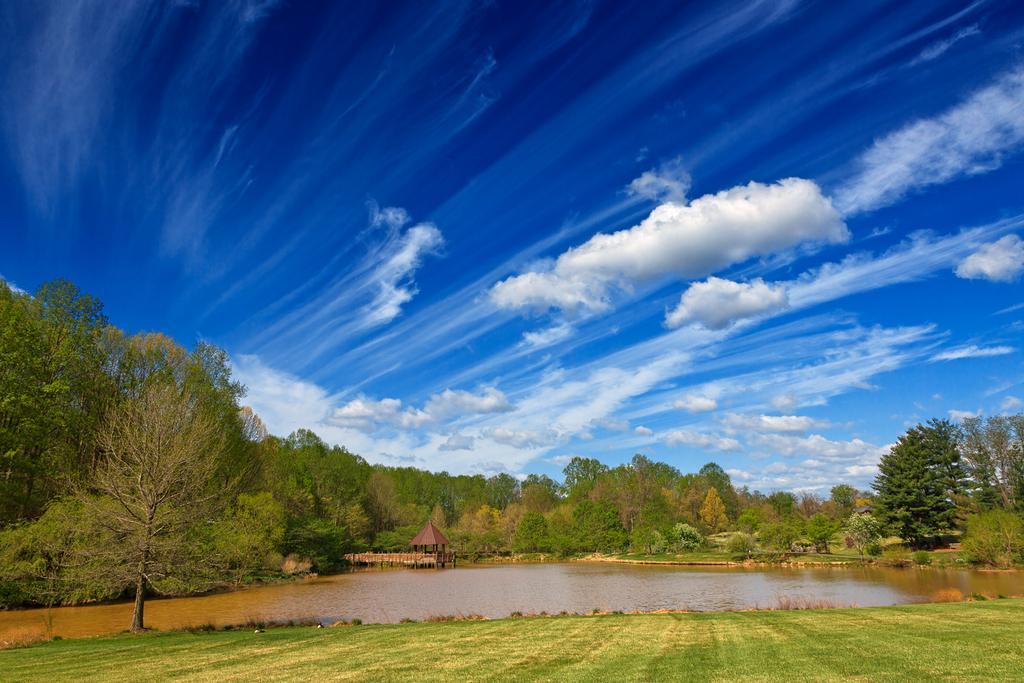How would you summarize this image in a sentence or two? This is an outside view. At the bottom of the image I can see the grass. In the middle of the image there is a sea. In the background, I can see many trees and a shed. At the top of the image I can see the sky and clouds. 